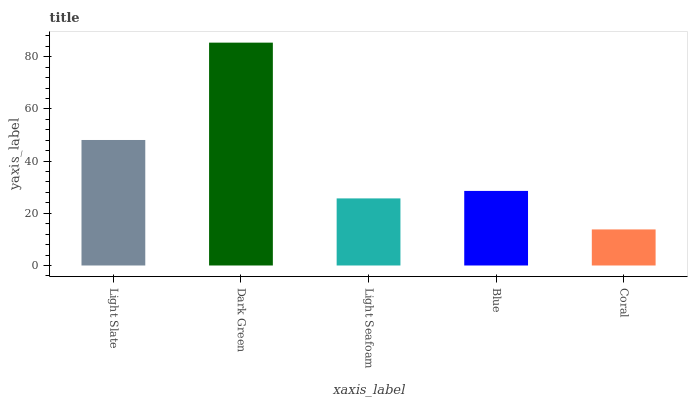Is Light Seafoam the minimum?
Answer yes or no. No. Is Light Seafoam the maximum?
Answer yes or no. No. Is Dark Green greater than Light Seafoam?
Answer yes or no. Yes. Is Light Seafoam less than Dark Green?
Answer yes or no. Yes. Is Light Seafoam greater than Dark Green?
Answer yes or no. No. Is Dark Green less than Light Seafoam?
Answer yes or no. No. Is Blue the high median?
Answer yes or no. Yes. Is Blue the low median?
Answer yes or no. Yes. Is Dark Green the high median?
Answer yes or no. No. Is Light Slate the low median?
Answer yes or no. No. 